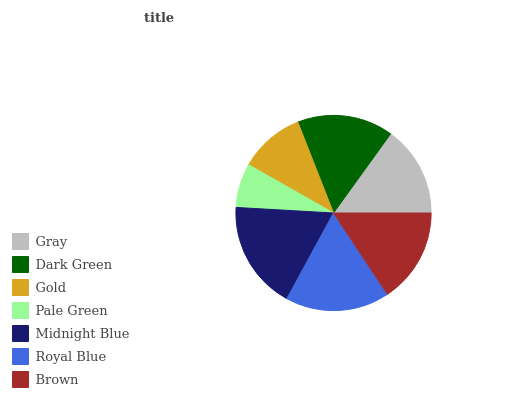Is Pale Green the minimum?
Answer yes or no. Yes. Is Midnight Blue the maximum?
Answer yes or no. Yes. Is Dark Green the minimum?
Answer yes or no. No. Is Dark Green the maximum?
Answer yes or no. No. Is Dark Green greater than Gray?
Answer yes or no. Yes. Is Gray less than Dark Green?
Answer yes or no. Yes. Is Gray greater than Dark Green?
Answer yes or no. No. Is Dark Green less than Gray?
Answer yes or no. No. Is Brown the high median?
Answer yes or no. Yes. Is Brown the low median?
Answer yes or no. Yes. Is Dark Green the high median?
Answer yes or no. No. Is Royal Blue the low median?
Answer yes or no. No. 